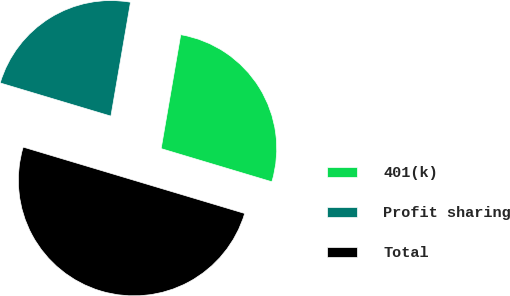Convert chart. <chart><loc_0><loc_0><loc_500><loc_500><pie_chart><fcel>401(k)<fcel>Profit sharing<fcel>Total<nl><fcel>26.92%<fcel>23.08%<fcel>50.0%<nl></chart> 